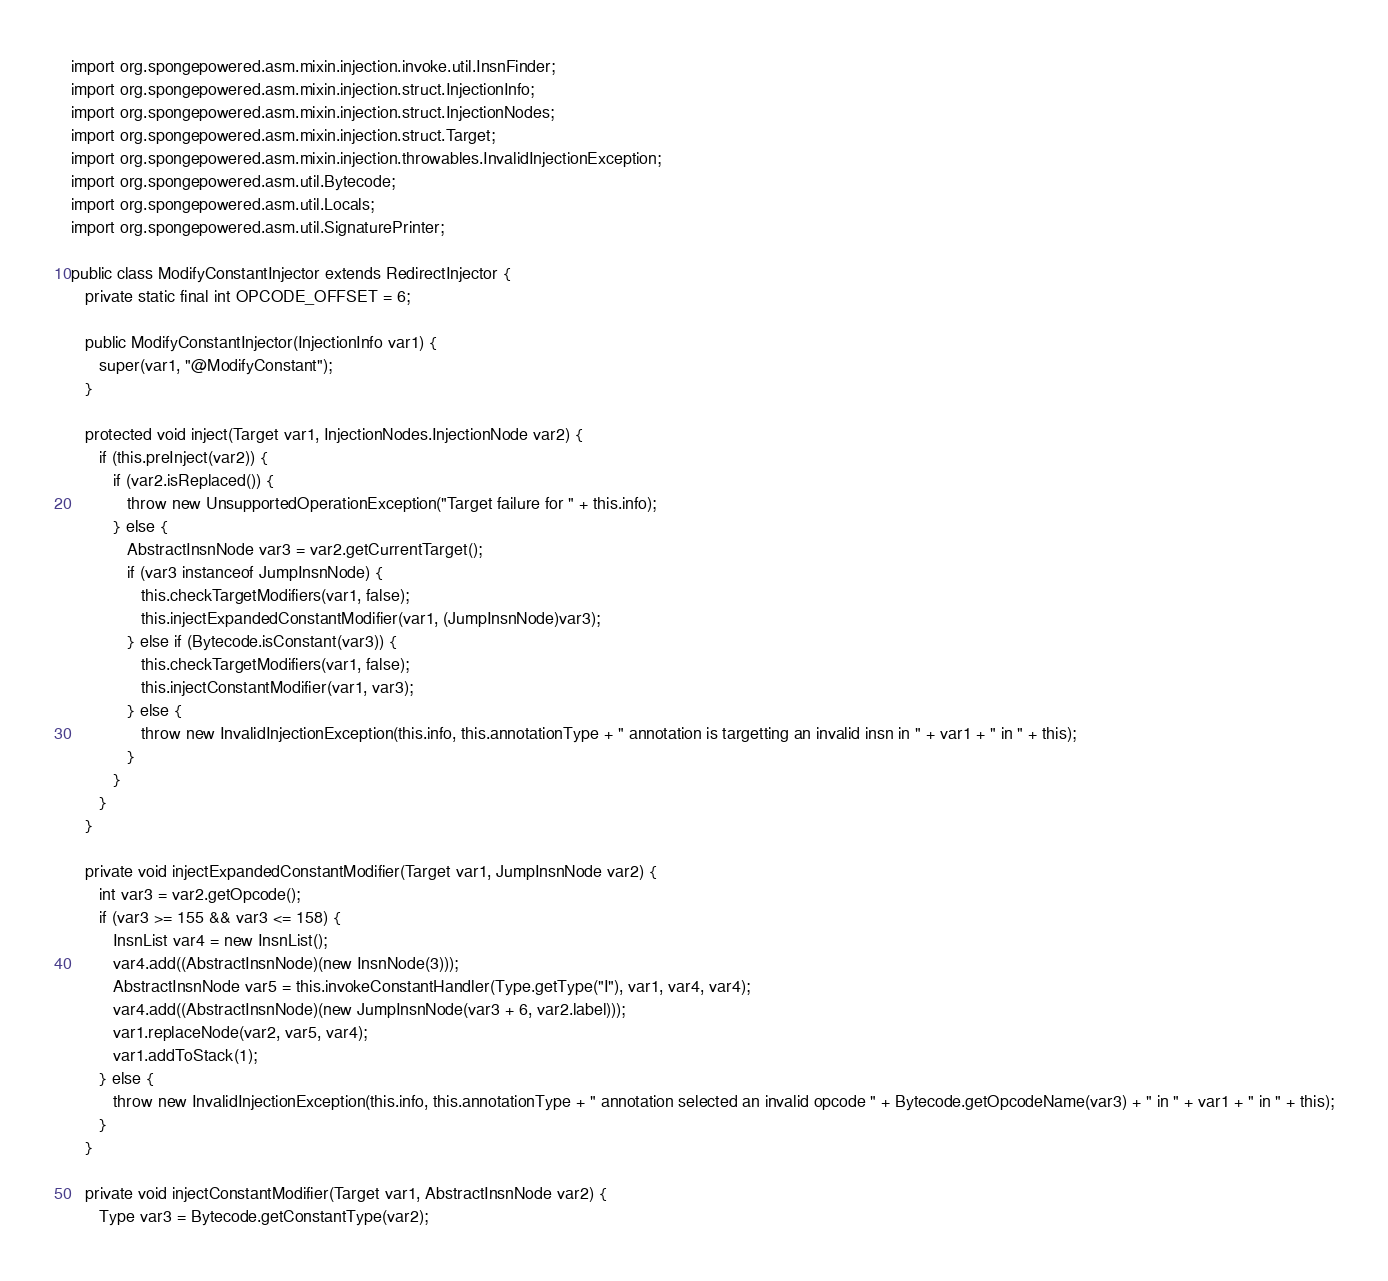Convert code to text. <code><loc_0><loc_0><loc_500><loc_500><_Java_>import org.spongepowered.asm.mixin.injection.invoke.util.InsnFinder;
import org.spongepowered.asm.mixin.injection.struct.InjectionInfo;
import org.spongepowered.asm.mixin.injection.struct.InjectionNodes;
import org.spongepowered.asm.mixin.injection.struct.Target;
import org.spongepowered.asm.mixin.injection.throwables.InvalidInjectionException;
import org.spongepowered.asm.util.Bytecode;
import org.spongepowered.asm.util.Locals;
import org.spongepowered.asm.util.SignaturePrinter;

public class ModifyConstantInjector extends RedirectInjector {
   private static final int OPCODE_OFFSET = 6;

   public ModifyConstantInjector(InjectionInfo var1) {
      super(var1, "@ModifyConstant");
   }

   protected void inject(Target var1, InjectionNodes.InjectionNode var2) {
      if (this.preInject(var2)) {
         if (var2.isReplaced()) {
            throw new UnsupportedOperationException("Target failure for " + this.info);
         } else {
            AbstractInsnNode var3 = var2.getCurrentTarget();
            if (var3 instanceof JumpInsnNode) {
               this.checkTargetModifiers(var1, false);
               this.injectExpandedConstantModifier(var1, (JumpInsnNode)var3);
            } else if (Bytecode.isConstant(var3)) {
               this.checkTargetModifiers(var1, false);
               this.injectConstantModifier(var1, var3);
            } else {
               throw new InvalidInjectionException(this.info, this.annotationType + " annotation is targetting an invalid insn in " + var1 + " in " + this);
            }
         }
      }
   }

   private void injectExpandedConstantModifier(Target var1, JumpInsnNode var2) {
      int var3 = var2.getOpcode();
      if (var3 >= 155 && var3 <= 158) {
         InsnList var4 = new InsnList();
         var4.add((AbstractInsnNode)(new InsnNode(3)));
         AbstractInsnNode var5 = this.invokeConstantHandler(Type.getType("I"), var1, var4, var4);
         var4.add((AbstractInsnNode)(new JumpInsnNode(var3 + 6, var2.label)));
         var1.replaceNode(var2, var5, var4);
         var1.addToStack(1);
      } else {
         throw new InvalidInjectionException(this.info, this.annotationType + " annotation selected an invalid opcode " + Bytecode.getOpcodeName(var3) + " in " + var1 + " in " + this);
      }
   }

   private void injectConstantModifier(Target var1, AbstractInsnNode var2) {
      Type var3 = Bytecode.getConstantType(var2);</code> 